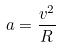<formula> <loc_0><loc_0><loc_500><loc_500>a = \frac { v ^ { 2 } } { R }</formula> 